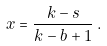Convert formula to latex. <formula><loc_0><loc_0><loc_500><loc_500>x = \frac { k - s } { k - b + 1 } \, .</formula> 